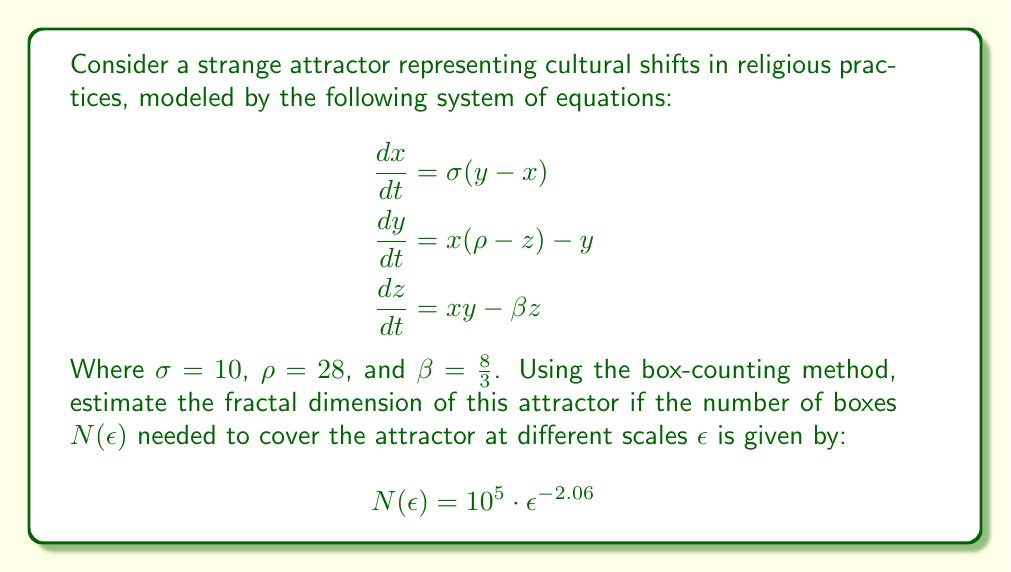Can you solve this math problem? To determine the fractal dimension of the strange attractor using the box-counting method, we follow these steps:

1) The box-counting dimension $D$ is defined as:

   $$D = \lim_{\epsilon \to 0} \frac{\log N(\epsilon)}{-\log \epsilon}$$

2) Given the relationship $N(\epsilon) = 10^5 \cdot \epsilon^{-2.06}$, we can simplify this equation:

   $$\begin{aligned}
   D &= \lim_{\epsilon \to 0} \frac{\log (10^5 \cdot \epsilon^{-2.06})}{-\log \epsilon} \\
   &= \lim_{\epsilon \to 0} \frac{\log 10^5 + \log \epsilon^{-2.06}}{-\log \epsilon} \\
   &= \lim_{\epsilon \to 0} \frac{\log 10^5 - 2.06 \log \epsilon}{-\log \epsilon}
   \end{aligned}$$

3) As $\epsilon \to 0$, $\log \epsilon \to -\infty$, so the $\log 10^5$ term becomes negligible:

   $$D = \lim_{\epsilon \to 0} \frac{- 2.06 \log \epsilon}{-\log \epsilon} = 2.06$$

4) Therefore, the fractal dimension of the strange attractor is approximately 2.06.

This fractal dimension between 2 and 3 indicates that the attractor fills more space than a 2D object but less than a 3D object, which is characteristic of strange attractors. In the context of cultural shifts in religious practices, this suggests a complex, non-linear system with sensitivity to initial conditions and patterns that repeat at different scales.
Answer: 2.06 